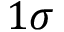Convert formula to latex. <formula><loc_0><loc_0><loc_500><loc_500>1 \sigma</formula> 